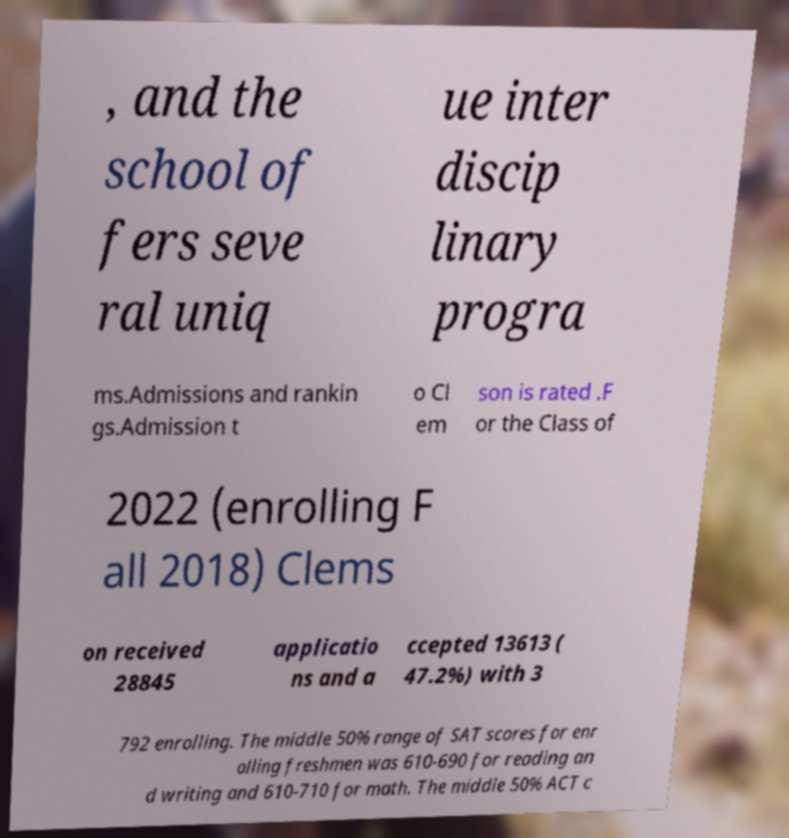There's text embedded in this image that I need extracted. Can you transcribe it verbatim? , and the school of fers seve ral uniq ue inter discip linary progra ms.Admissions and rankin gs.Admission t o Cl em son is rated .F or the Class of 2022 (enrolling F all 2018) Clems on received 28845 applicatio ns and a ccepted 13613 ( 47.2%) with 3 792 enrolling. The middle 50% range of SAT scores for enr olling freshmen was 610-690 for reading an d writing and 610-710 for math. The middle 50% ACT c 